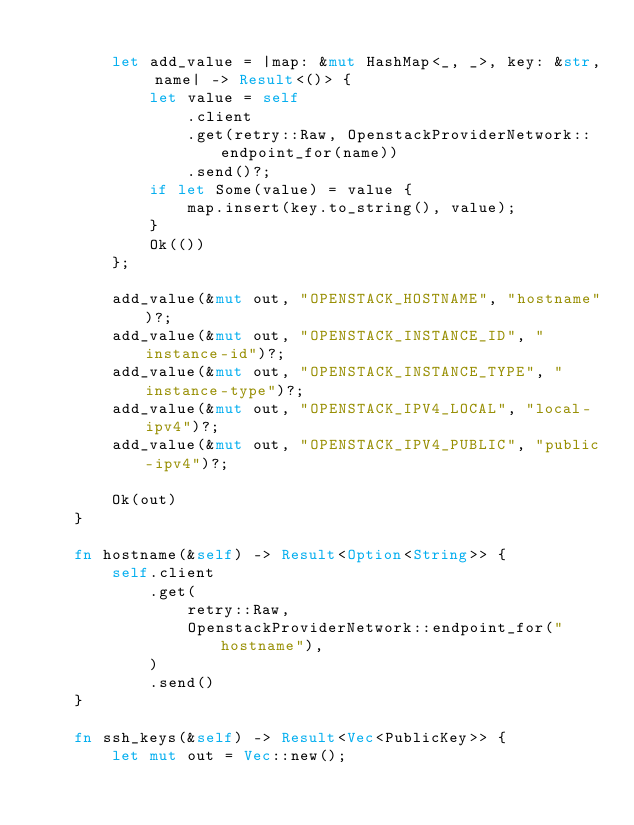Convert code to text. <code><loc_0><loc_0><loc_500><loc_500><_Rust_>
        let add_value = |map: &mut HashMap<_, _>, key: &str, name| -> Result<()> {
            let value = self
                .client
                .get(retry::Raw, OpenstackProviderNetwork::endpoint_for(name))
                .send()?;
            if let Some(value) = value {
                map.insert(key.to_string(), value);
            }
            Ok(())
        };

        add_value(&mut out, "OPENSTACK_HOSTNAME", "hostname")?;
        add_value(&mut out, "OPENSTACK_INSTANCE_ID", "instance-id")?;
        add_value(&mut out, "OPENSTACK_INSTANCE_TYPE", "instance-type")?;
        add_value(&mut out, "OPENSTACK_IPV4_LOCAL", "local-ipv4")?;
        add_value(&mut out, "OPENSTACK_IPV4_PUBLIC", "public-ipv4")?;

        Ok(out)
    }

    fn hostname(&self) -> Result<Option<String>> {
        self.client
            .get(
                retry::Raw,
                OpenstackProviderNetwork::endpoint_for("hostname"),
            )
            .send()
    }

    fn ssh_keys(&self) -> Result<Vec<PublicKey>> {
        let mut out = Vec::new();
</code> 